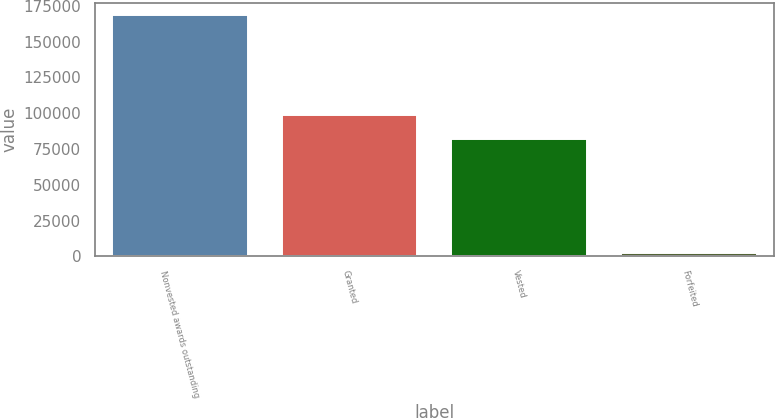<chart> <loc_0><loc_0><loc_500><loc_500><bar_chart><fcel>Nonvested awards outstanding<fcel>Granted<fcel>Vested<fcel>Forfeited<nl><fcel>168540<fcel>98900<fcel>82000<fcel>2300<nl></chart> 